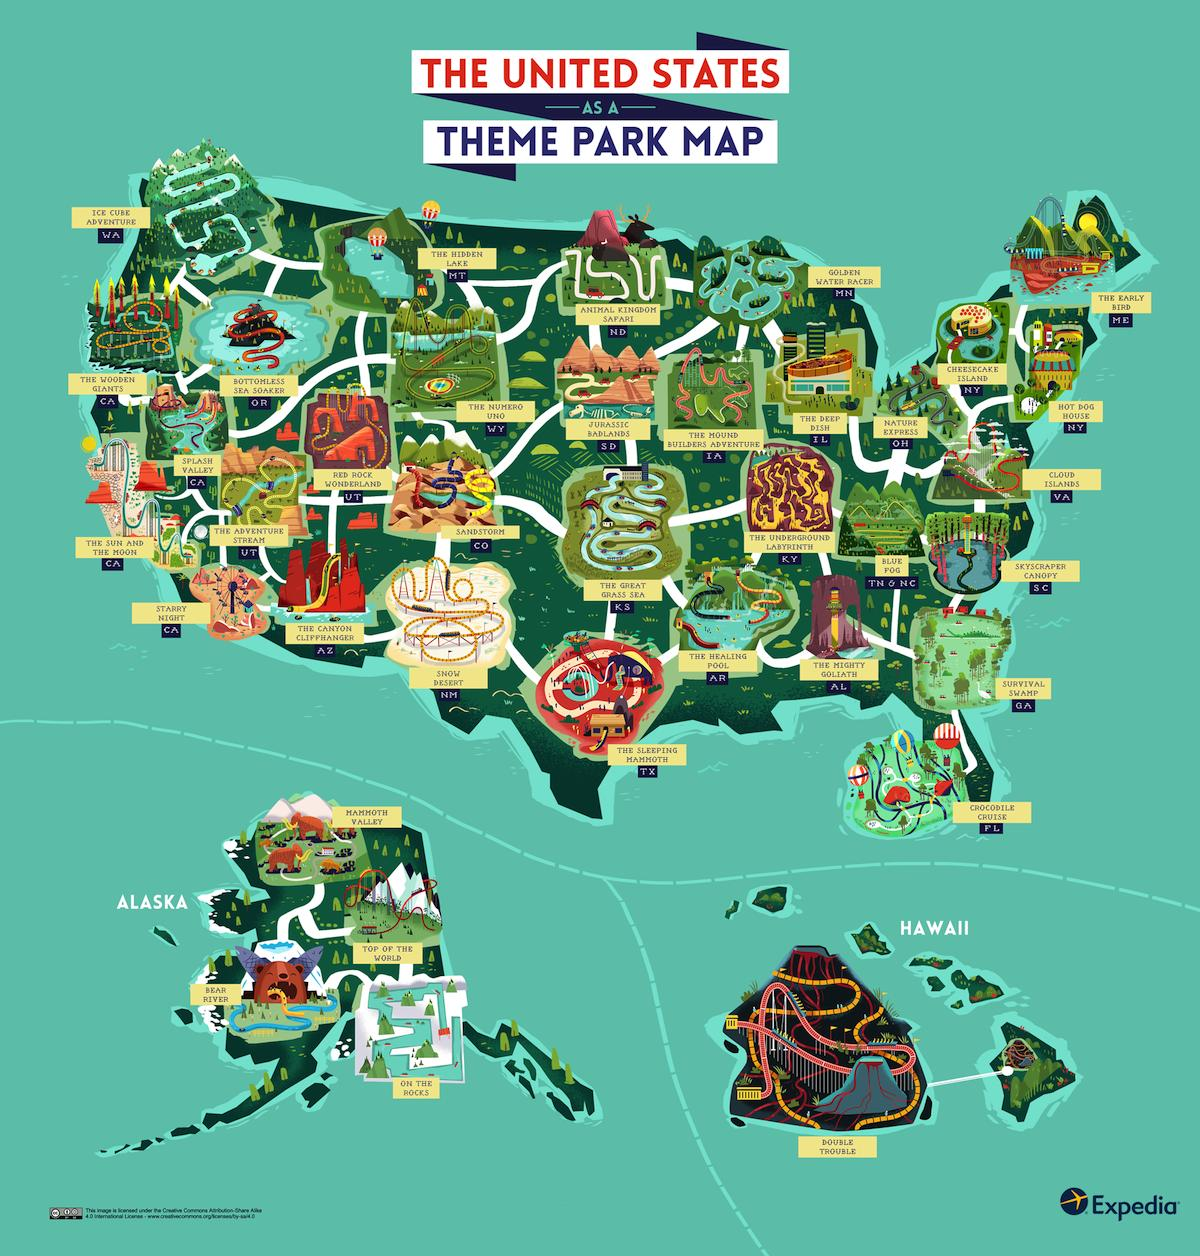Outline some significant characteristics in this image. There are four parks in Alaska. The desert is covered in snow. The park in Hawaii named Double Trouble. The sleeping mammoth is located in a park in Texas. There are two parks in New York. 